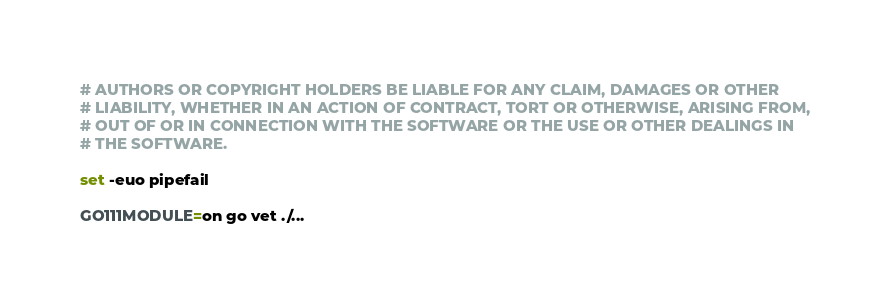<code> <loc_0><loc_0><loc_500><loc_500><_Bash_># AUTHORS OR COPYRIGHT HOLDERS BE LIABLE FOR ANY CLAIM, DAMAGES OR OTHER
# LIABILITY, WHETHER IN AN ACTION OF CONTRACT, TORT OR OTHERWISE, ARISING FROM,
# OUT OF OR IN CONNECTION WITH THE SOFTWARE OR THE USE OR OTHER DEALINGS IN
# THE SOFTWARE.

set -euo pipefail

GO111MODULE=on go vet ./...
</code> 